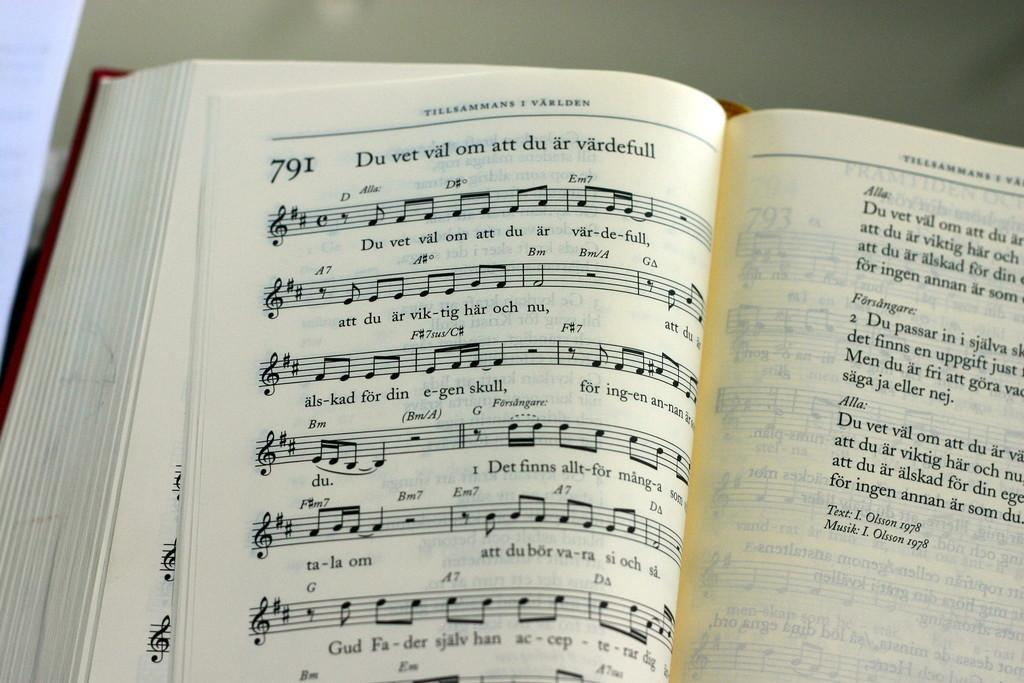<image>
Offer a succinct explanation of the picture presented. A book of sheet music is opened to page 791. 